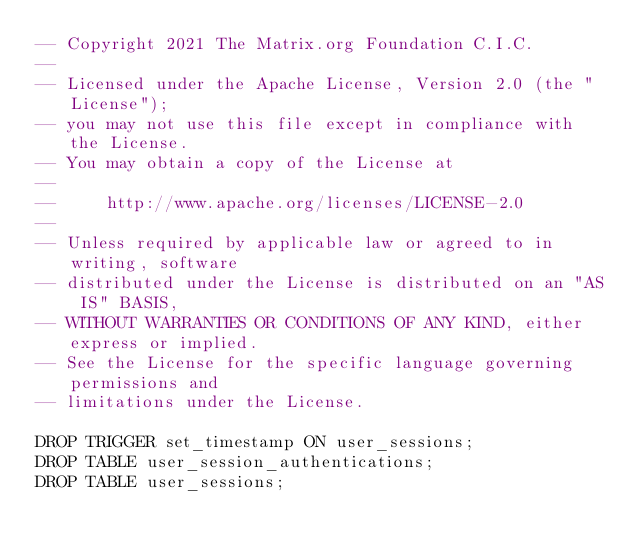<code> <loc_0><loc_0><loc_500><loc_500><_SQL_>-- Copyright 2021 The Matrix.org Foundation C.I.C.
--
-- Licensed under the Apache License, Version 2.0 (the "License");
-- you may not use this file except in compliance with the License.
-- You may obtain a copy of the License at
--
--     http://www.apache.org/licenses/LICENSE-2.0
--
-- Unless required by applicable law or agreed to in writing, software
-- distributed under the License is distributed on an "AS IS" BASIS,
-- WITHOUT WARRANTIES OR CONDITIONS OF ANY KIND, either express or implied.
-- See the License for the specific language governing permissions and
-- limitations under the License.

DROP TRIGGER set_timestamp ON user_sessions;
DROP TABLE user_session_authentications;
DROP TABLE user_sessions;
</code> 